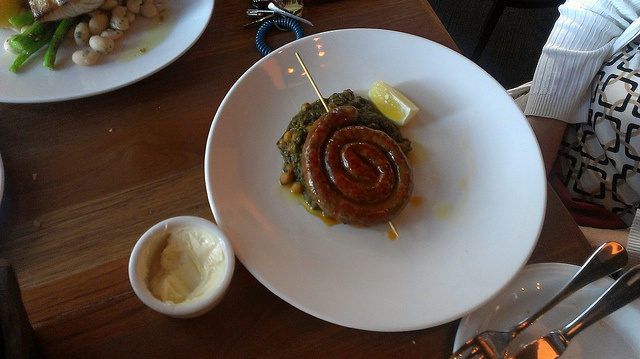Describe the objects in this image and their specific colors. I can see dining table in olive, black, maroon, and darkgray tones, people in olive, black, gray, darkgray, and lightblue tones, bowl in olive, darkgray, and gray tones, fork in olive, black, maroon, and gray tones, and knife in olive, black, maroon, gray, and orange tones in this image. 